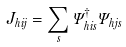Convert formula to latex. <formula><loc_0><loc_0><loc_500><loc_500>J _ { h i j } = \sum _ { s } \Psi _ { h i s } ^ { \dagger } \Psi _ { h j s }</formula> 